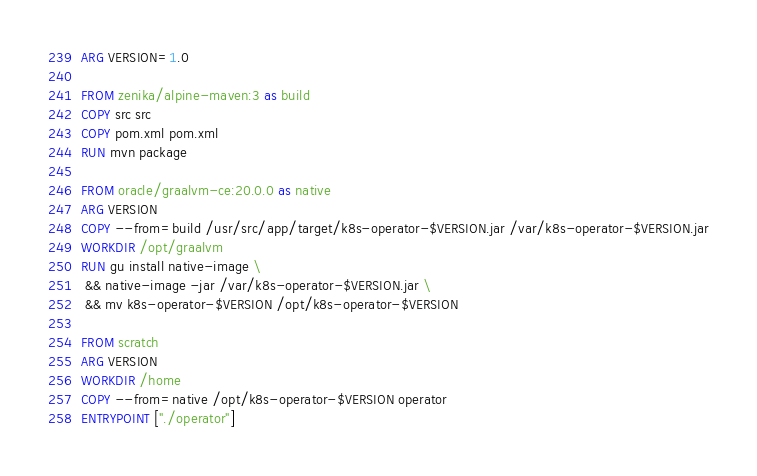<code> <loc_0><loc_0><loc_500><loc_500><_Dockerfile_>
ARG VERSION=1.0

FROM zenika/alpine-maven:3 as build
COPY src src
COPY pom.xml pom.xml
RUN mvn package

FROM oracle/graalvm-ce:20.0.0 as native
ARG VERSION
COPY --from=build /usr/src/app/target/k8s-operator-$VERSION.jar /var/k8s-operator-$VERSION.jar
WORKDIR /opt/graalvm
RUN gu install native-image \
 && native-image -jar /var/k8s-operator-$VERSION.jar \
 && mv k8s-operator-$VERSION /opt/k8s-operator-$VERSION

FROM scratch
ARG VERSION
WORKDIR /home
COPY --from=native /opt/k8s-operator-$VERSION operator
ENTRYPOINT ["./operator"]</code> 